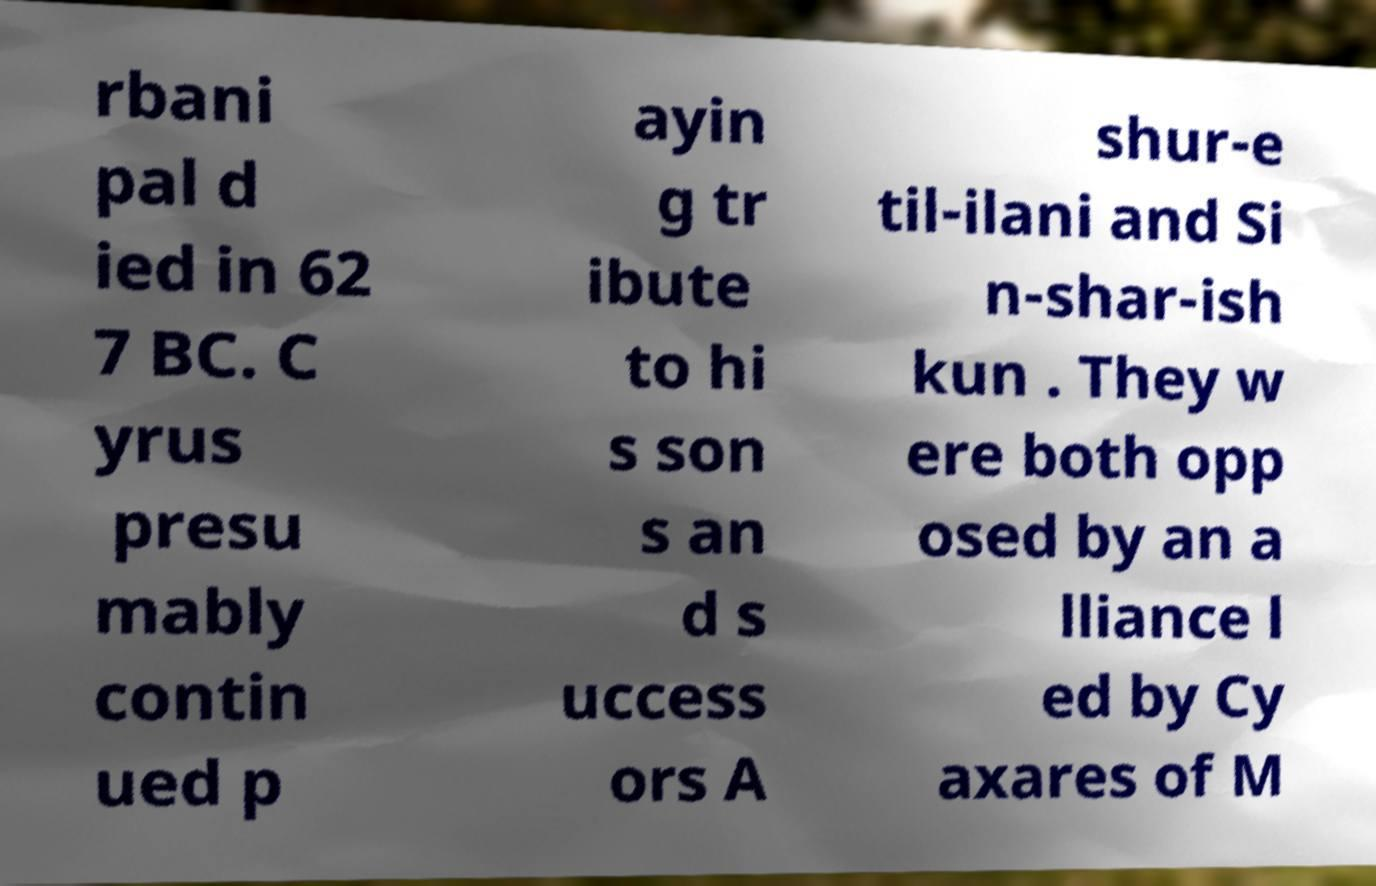Can you accurately transcribe the text from the provided image for me? rbani pal d ied in 62 7 BC. C yrus presu mably contin ued p ayin g tr ibute to hi s son s an d s uccess ors A shur-e til-ilani and Si n-shar-ish kun . They w ere both opp osed by an a lliance l ed by Cy axares of M 